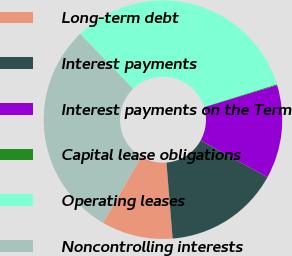Convert chart. <chart><loc_0><loc_0><loc_500><loc_500><pie_chart><fcel>Long-term debt<fcel>Interest payments<fcel>Interest payments on the Term<fcel>Capital lease obligations<fcel>Operating leases<fcel>Noncontrolling interests<nl><fcel>9.67%<fcel>15.7%<fcel>12.69%<fcel>0.13%<fcel>32.41%<fcel>29.4%<nl></chart> 